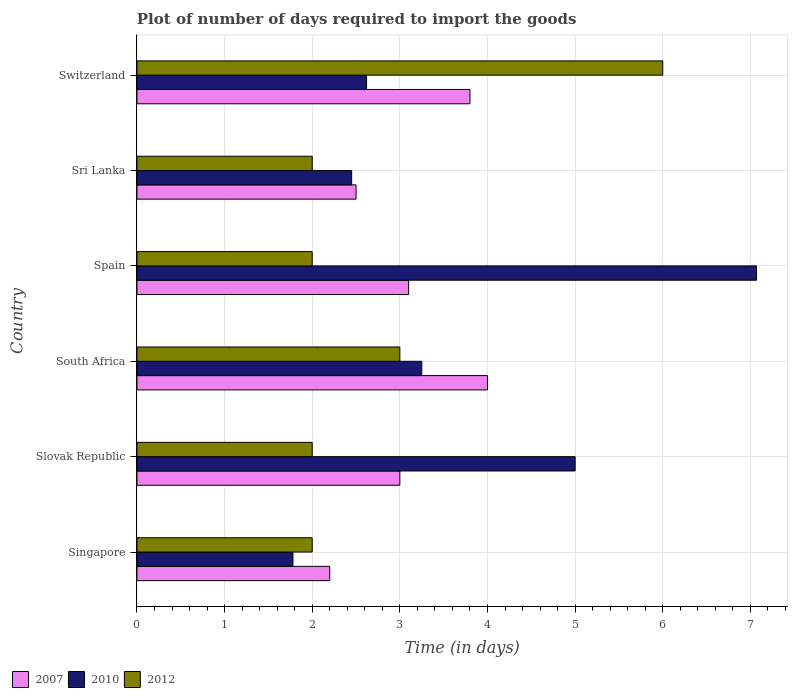How many different coloured bars are there?
Your response must be concise. 3. Are the number of bars per tick equal to the number of legend labels?
Provide a short and direct response. Yes. How many bars are there on the 5th tick from the top?
Keep it short and to the point. 3. How many bars are there on the 3rd tick from the bottom?
Your response must be concise. 3. What is the label of the 4th group of bars from the top?
Give a very brief answer. South Africa. In how many cases, is the number of bars for a given country not equal to the number of legend labels?
Give a very brief answer. 0. What is the time required to import goods in 2010 in Switzerland?
Ensure brevity in your answer.  2.62. Across all countries, what is the maximum time required to import goods in 2010?
Provide a short and direct response. 7.07. Across all countries, what is the minimum time required to import goods in 2010?
Provide a short and direct response. 1.78. In which country was the time required to import goods in 2007 maximum?
Give a very brief answer. South Africa. In which country was the time required to import goods in 2012 minimum?
Keep it short and to the point. Singapore. What is the total time required to import goods in 2007 in the graph?
Your answer should be very brief. 18.6. What is the difference between the time required to import goods in 2010 in Singapore and that in Slovak Republic?
Offer a terse response. -3.22. What is the average time required to import goods in 2007 per country?
Your answer should be compact. 3.1. What is the difference between the time required to import goods in 2007 and time required to import goods in 2010 in Sri Lanka?
Offer a very short reply. 0.05. In how many countries, is the time required to import goods in 2012 greater than 6.2 days?
Ensure brevity in your answer.  0. What is the ratio of the time required to import goods in 2010 in Singapore to that in Slovak Republic?
Provide a short and direct response. 0.36. Is the time required to import goods in 2007 in Singapore less than that in South Africa?
Ensure brevity in your answer.  Yes. What is the difference between the highest and the second highest time required to import goods in 2012?
Ensure brevity in your answer.  3. What is the difference between the highest and the lowest time required to import goods in 2010?
Provide a succinct answer. 5.29. What does the 2nd bar from the bottom in Spain represents?
Keep it short and to the point. 2010. Is it the case that in every country, the sum of the time required to import goods in 2007 and time required to import goods in 2010 is greater than the time required to import goods in 2012?
Your answer should be compact. Yes. How many bars are there?
Offer a very short reply. 18. Are all the bars in the graph horizontal?
Your response must be concise. Yes. What is the difference between two consecutive major ticks on the X-axis?
Offer a terse response. 1. Where does the legend appear in the graph?
Provide a short and direct response. Bottom left. How are the legend labels stacked?
Provide a short and direct response. Horizontal. What is the title of the graph?
Your response must be concise. Plot of number of days required to import the goods. Does "1972" appear as one of the legend labels in the graph?
Provide a short and direct response. No. What is the label or title of the X-axis?
Make the answer very short. Time (in days). What is the label or title of the Y-axis?
Your answer should be very brief. Country. What is the Time (in days) of 2010 in Singapore?
Your answer should be compact. 1.78. What is the Time (in days) of 2012 in Singapore?
Keep it short and to the point. 2. What is the Time (in days) in 2012 in Slovak Republic?
Give a very brief answer. 2. What is the Time (in days) in 2007 in South Africa?
Make the answer very short. 4. What is the Time (in days) in 2010 in South Africa?
Your response must be concise. 3.25. What is the Time (in days) in 2010 in Spain?
Your answer should be very brief. 7.07. What is the Time (in days) in 2012 in Spain?
Provide a succinct answer. 2. What is the Time (in days) of 2010 in Sri Lanka?
Provide a short and direct response. 2.45. What is the Time (in days) of 2010 in Switzerland?
Offer a terse response. 2.62. Across all countries, what is the maximum Time (in days) in 2010?
Make the answer very short. 7.07. Across all countries, what is the minimum Time (in days) in 2010?
Keep it short and to the point. 1.78. Across all countries, what is the minimum Time (in days) in 2012?
Your response must be concise. 2. What is the total Time (in days) of 2007 in the graph?
Give a very brief answer. 18.6. What is the total Time (in days) in 2010 in the graph?
Offer a terse response. 22.17. What is the difference between the Time (in days) of 2007 in Singapore and that in Slovak Republic?
Your response must be concise. -0.8. What is the difference between the Time (in days) of 2010 in Singapore and that in Slovak Republic?
Provide a short and direct response. -3.22. What is the difference between the Time (in days) in 2007 in Singapore and that in South Africa?
Your answer should be compact. -1.8. What is the difference between the Time (in days) in 2010 in Singapore and that in South Africa?
Give a very brief answer. -1.47. What is the difference between the Time (in days) of 2010 in Singapore and that in Spain?
Make the answer very short. -5.29. What is the difference between the Time (in days) in 2012 in Singapore and that in Spain?
Ensure brevity in your answer.  0. What is the difference between the Time (in days) of 2007 in Singapore and that in Sri Lanka?
Provide a succinct answer. -0.3. What is the difference between the Time (in days) in 2010 in Singapore and that in Sri Lanka?
Your response must be concise. -0.67. What is the difference between the Time (in days) in 2007 in Singapore and that in Switzerland?
Provide a succinct answer. -1.6. What is the difference between the Time (in days) in 2010 in Singapore and that in Switzerland?
Provide a succinct answer. -0.84. What is the difference between the Time (in days) in 2012 in Singapore and that in Switzerland?
Provide a short and direct response. -4. What is the difference between the Time (in days) in 2007 in Slovak Republic and that in South Africa?
Give a very brief answer. -1. What is the difference between the Time (in days) in 2012 in Slovak Republic and that in South Africa?
Ensure brevity in your answer.  -1. What is the difference between the Time (in days) in 2010 in Slovak Republic and that in Spain?
Provide a succinct answer. -2.07. What is the difference between the Time (in days) of 2010 in Slovak Republic and that in Sri Lanka?
Provide a short and direct response. 2.55. What is the difference between the Time (in days) in 2010 in Slovak Republic and that in Switzerland?
Provide a short and direct response. 2.38. What is the difference between the Time (in days) of 2010 in South Africa and that in Spain?
Offer a very short reply. -3.82. What is the difference between the Time (in days) in 2010 in South Africa and that in Sri Lanka?
Keep it short and to the point. 0.8. What is the difference between the Time (in days) of 2007 in South Africa and that in Switzerland?
Provide a succinct answer. 0.2. What is the difference between the Time (in days) of 2010 in South Africa and that in Switzerland?
Your answer should be very brief. 0.63. What is the difference between the Time (in days) in 2007 in Spain and that in Sri Lanka?
Make the answer very short. 0.6. What is the difference between the Time (in days) of 2010 in Spain and that in Sri Lanka?
Ensure brevity in your answer.  4.62. What is the difference between the Time (in days) of 2012 in Spain and that in Sri Lanka?
Offer a terse response. 0. What is the difference between the Time (in days) in 2007 in Spain and that in Switzerland?
Ensure brevity in your answer.  -0.7. What is the difference between the Time (in days) in 2010 in Spain and that in Switzerland?
Keep it short and to the point. 4.45. What is the difference between the Time (in days) in 2010 in Sri Lanka and that in Switzerland?
Offer a very short reply. -0.17. What is the difference between the Time (in days) of 2010 in Singapore and the Time (in days) of 2012 in Slovak Republic?
Keep it short and to the point. -0.22. What is the difference between the Time (in days) of 2007 in Singapore and the Time (in days) of 2010 in South Africa?
Offer a terse response. -1.05. What is the difference between the Time (in days) of 2007 in Singapore and the Time (in days) of 2012 in South Africa?
Make the answer very short. -0.8. What is the difference between the Time (in days) in 2010 in Singapore and the Time (in days) in 2012 in South Africa?
Make the answer very short. -1.22. What is the difference between the Time (in days) in 2007 in Singapore and the Time (in days) in 2010 in Spain?
Give a very brief answer. -4.87. What is the difference between the Time (in days) of 2007 in Singapore and the Time (in days) of 2012 in Spain?
Your response must be concise. 0.2. What is the difference between the Time (in days) in 2010 in Singapore and the Time (in days) in 2012 in Spain?
Offer a terse response. -0.22. What is the difference between the Time (in days) in 2007 in Singapore and the Time (in days) in 2010 in Sri Lanka?
Your response must be concise. -0.25. What is the difference between the Time (in days) of 2007 in Singapore and the Time (in days) of 2012 in Sri Lanka?
Make the answer very short. 0.2. What is the difference between the Time (in days) in 2010 in Singapore and the Time (in days) in 2012 in Sri Lanka?
Provide a short and direct response. -0.22. What is the difference between the Time (in days) in 2007 in Singapore and the Time (in days) in 2010 in Switzerland?
Make the answer very short. -0.42. What is the difference between the Time (in days) in 2007 in Singapore and the Time (in days) in 2012 in Switzerland?
Provide a short and direct response. -3.8. What is the difference between the Time (in days) of 2010 in Singapore and the Time (in days) of 2012 in Switzerland?
Offer a terse response. -4.22. What is the difference between the Time (in days) in 2007 in Slovak Republic and the Time (in days) in 2010 in Spain?
Give a very brief answer. -4.07. What is the difference between the Time (in days) in 2007 in Slovak Republic and the Time (in days) in 2012 in Spain?
Ensure brevity in your answer.  1. What is the difference between the Time (in days) in 2007 in Slovak Republic and the Time (in days) in 2010 in Sri Lanka?
Ensure brevity in your answer.  0.55. What is the difference between the Time (in days) of 2010 in Slovak Republic and the Time (in days) of 2012 in Sri Lanka?
Provide a short and direct response. 3. What is the difference between the Time (in days) of 2007 in Slovak Republic and the Time (in days) of 2010 in Switzerland?
Keep it short and to the point. 0.38. What is the difference between the Time (in days) in 2007 in Slovak Republic and the Time (in days) in 2012 in Switzerland?
Offer a very short reply. -3. What is the difference between the Time (in days) of 2007 in South Africa and the Time (in days) of 2010 in Spain?
Your answer should be compact. -3.07. What is the difference between the Time (in days) in 2010 in South Africa and the Time (in days) in 2012 in Spain?
Give a very brief answer. 1.25. What is the difference between the Time (in days) in 2007 in South Africa and the Time (in days) in 2010 in Sri Lanka?
Your response must be concise. 1.55. What is the difference between the Time (in days) in 2010 in South Africa and the Time (in days) in 2012 in Sri Lanka?
Offer a very short reply. 1.25. What is the difference between the Time (in days) of 2007 in South Africa and the Time (in days) of 2010 in Switzerland?
Ensure brevity in your answer.  1.38. What is the difference between the Time (in days) in 2010 in South Africa and the Time (in days) in 2012 in Switzerland?
Keep it short and to the point. -2.75. What is the difference between the Time (in days) in 2007 in Spain and the Time (in days) in 2010 in Sri Lanka?
Provide a short and direct response. 0.65. What is the difference between the Time (in days) of 2007 in Spain and the Time (in days) of 2012 in Sri Lanka?
Your answer should be compact. 1.1. What is the difference between the Time (in days) of 2010 in Spain and the Time (in days) of 2012 in Sri Lanka?
Offer a very short reply. 5.07. What is the difference between the Time (in days) of 2007 in Spain and the Time (in days) of 2010 in Switzerland?
Your answer should be compact. 0.48. What is the difference between the Time (in days) in 2010 in Spain and the Time (in days) in 2012 in Switzerland?
Give a very brief answer. 1.07. What is the difference between the Time (in days) of 2007 in Sri Lanka and the Time (in days) of 2010 in Switzerland?
Keep it short and to the point. -0.12. What is the difference between the Time (in days) of 2010 in Sri Lanka and the Time (in days) of 2012 in Switzerland?
Your answer should be very brief. -3.55. What is the average Time (in days) in 2007 per country?
Ensure brevity in your answer.  3.1. What is the average Time (in days) of 2010 per country?
Provide a short and direct response. 3.69. What is the average Time (in days) of 2012 per country?
Offer a terse response. 2.83. What is the difference between the Time (in days) in 2007 and Time (in days) in 2010 in Singapore?
Offer a terse response. 0.42. What is the difference between the Time (in days) in 2007 and Time (in days) in 2012 in Singapore?
Offer a very short reply. 0.2. What is the difference between the Time (in days) of 2010 and Time (in days) of 2012 in Singapore?
Provide a short and direct response. -0.22. What is the difference between the Time (in days) in 2007 and Time (in days) in 2010 in Slovak Republic?
Give a very brief answer. -2. What is the difference between the Time (in days) in 2007 and Time (in days) in 2012 in South Africa?
Ensure brevity in your answer.  1. What is the difference between the Time (in days) in 2007 and Time (in days) in 2010 in Spain?
Your answer should be compact. -3.97. What is the difference between the Time (in days) in 2010 and Time (in days) in 2012 in Spain?
Provide a succinct answer. 5.07. What is the difference between the Time (in days) of 2007 and Time (in days) of 2012 in Sri Lanka?
Offer a very short reply. 0.5. What is the difference between the Time (in days) of 2010 and Time (in days) of 2012 in Sri Lanka?
Offer a terse response. 0.45. What is the difference between the Time (in days) in 2007 and Time (in days) in 2010 in Switzerland?
Provide a short and direct response. 1.18. What is the difference between the Time (in days) in 2010 and Time (in days) in 2012 in Switzerland?
Your answer should be very brief. -3.38. What is the ratio of the Time (in days) in 2007 in Singapore to that in Slovak Republic?
Provide a short and direct response. 0.73. What is the ratio of the Time (in days) of 2010 in Singapore to that in Slovak Republic?
Provide a short and direct response. 0.36. What is the ratio of the Time (in days) of 2007 in Singapore to that in South Africa?
Make the answer very short. 0.55. What is the ratio of the Time (in days) in 2010 in Singapore to that in South Africa?
Your answer should be compact. 0.55. What is the ratio of the Time (in days) in 2007 in Singapore to that in Spain?
Provide a succinct answer. 0.71. What is the ratio of the Time (in days) in 2010 in Singapore to that in Spain?
Give a very brief answer. 0.25. What is the ratio of the Time (in days) in 2012 in Singapore to that in Spain?
Offer a very short reply. 1. What is the ratio of the Time (in days) in 2010 in Singapore to that in Sri Lanka?
Give a very brief answer. 0.73. What is the ratio of the Time (in days) in 2007 in Singapore to that in Switzerland?
Offer a terse response. 0.58. What is the ratio of the Time (in days) of 2010 in Singapore to that in Switzerland?
Ensure brevity in your answer.  0.68. What is the ratio of the Time (in days) of 2012 in Singapore to that in Switzerland?
Your answer should be very brief. 0.33. What is the ratio of the Time (in days) of 2010 in Slovak Republic to that in South Africa?
Offer a very short reply. 1.54. What is the ratio of the Time (in days) in 2012 in Slovak Republic to that in South Africa?
Keep it short and to the point. 0.67. What is the ratio of the Time (in days) of 2010 in Slovak Republic to that in Spain?
Ensure brevity in your answer.  0.71. What is the ratio of the Time (in days) in 2010 in Slovak Republic to that in Sri Lanka?
Your response must be concise. 2.04. What is the ratio of the Time (in days) in 2007 in Slovak Republic to that in Switzerland?
Provide a short and direct response. 0.79. What is the ratio of the Time (in days) in 2010 in Slovak Republic to that in Switzerland?
Provide a short and direct response. 1.91. What is the ratio of the Time (in days) of 2007 in South Africa to that in Spain?
Make the answer very short. 1.29. What is the ratio of the Time (in days) of 2010 in South Africa to that in Spain?
Provide a short and direct response. 0.46. What is the ratio of the Time (in days) in 2010 in South Africa to that in Sri Lanka?
Provide a succinct answer. 1.33. What is the ratio of the Time (in days) of 2012 in South Africa to that in Sri Lanka?
Your answer should be compact. 1.5. What is the ratio of the Time (in days) of 2007 in South Africa to that in Switzerland?
Offer a terse response. 1.05. What is the ratio of the Time (in days) of 2010 in South Africa to that in Switzerland?
Your answer should be very brief. 1.24. What is the ratio of the Time (in days) of 2007 in Spain to that in Sri Lanka?
Offer a terse response. 1.24. What is the ratio of the Time (in days) in 2010 in Spain to that in Sri Lanka?
Provide a succinct answer. 2.89. What is the ratio of the Time (in days) in 2012 in Spain to that in Sri Lanka?
Make the answer very short. 1. What is the ratio of the Time (in days) of 2007 in Spain to that in Switzerland?
Ensure brevity in your answer.  0.82. What is the ratio of the Time (in days) in 2010 in Spain to that in Switzerland?
Your answer should be compact. 2.7. What is the ratio of the Time (in days) of 2012 in Spain to that in Switzerland?
Provide a short and direct response. 0.33. What is the ratio of the Time (in days) in 2007 in Sri Lanka to that in Switzerland?
Your answer should be compact. 0.66. What is the ratio of the Time (in days) in 2010 in Sri Lanka to that in Switzerland?
Make the answer very short. 0.94. What is the ratio of the Time (in days) in 2012 in Sri Lanka to that in Switzerland?
Keep it short and to the point. 0.33. What is the difference between the highest and the second highest Time (in days) of 2007?
Provide a short and direct response. 0.2. What is the difference between the highest and the second highest Time (in days) of 2010?
Give a very brief answer. 2.07. What is the difference between the highest and the lowest Time (in days) in 2010?
Your answer should be very brief. 5.29. 